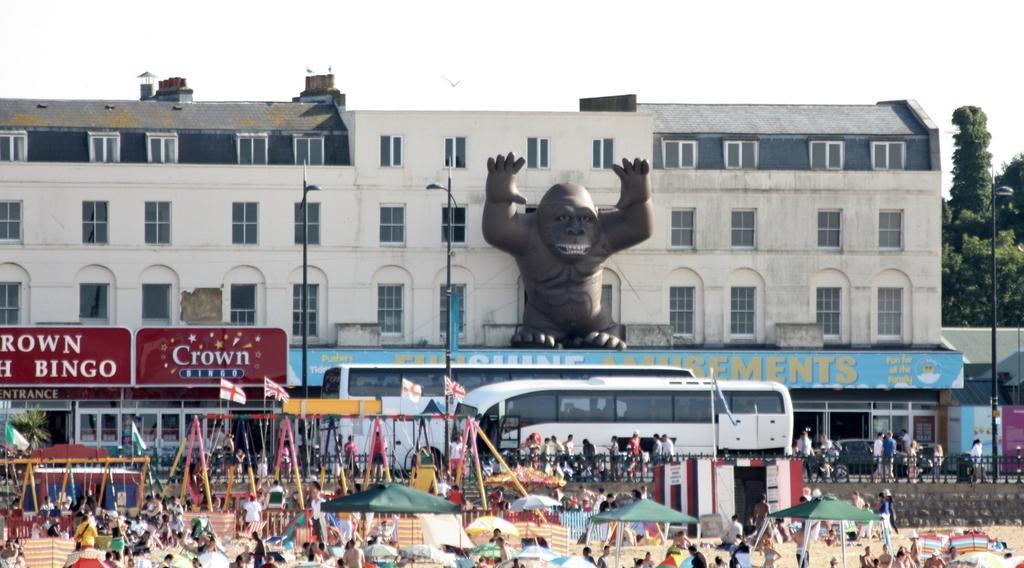In one or two sentences, can you explain what this image depicts? In this image I can see group of people, some are standing and some are walking. I can also see few tents in green color, background I can see few poles in multi color, few vehicles. I can also see few boards attached to the buildings and the buildings are in white and cream color and I can also see an animal statue, few light poles, trees in green color and the sky is in white color. 